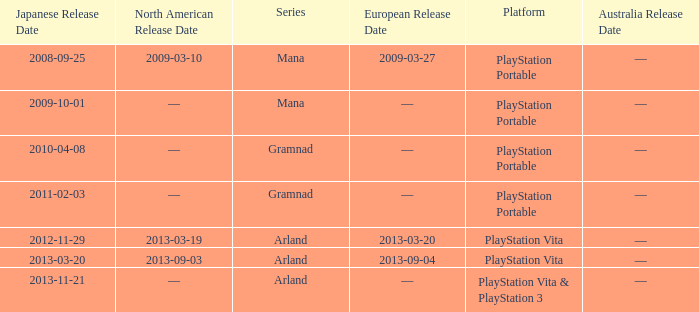What is the series with a North American release date on 2013-09-03? Arland. 